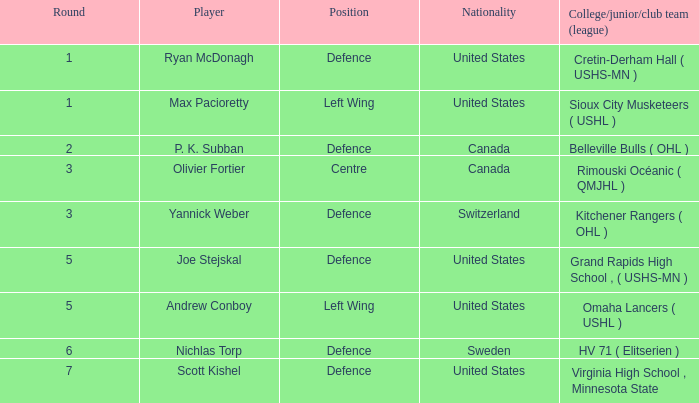Could you parse the entire table as a dict? {'header': ['Round', 'Player', 'Position', 'Nationality', 'College/junior/club team (league)'], 'rows': [['1', 'Ryan McDonagh', 'Defence', 'United States', 'Cretin-Derham Hall ( USHS-MN )'], ['1', 'Max Pacioretty', 'Left Wing', 'United States', 'Sioux City Musketeers ( USHL )'], ['2', 'P. K. Subban', 'Defence', 'Canada', 'Belleville Bulls ( OHL )'], ['3', 'Olivier Fortier', 'Centre', 'Canada', 'Rimouski Océanic ( QMJHL )'], ['3', 'Yannick Weber', 'Defence', 'Switzerland', 'Kitchener Rangers ( OHL )'], ['5', 'Joe Stejskal', 'Defence', 'United States', 'Grand Rapids High School , ( USHS-MN )'], ['5', 'Andrew Conboy', 'Left Wing', 'United States', 'Omaha Lancers ( USHL )'], ['6', 'Nichlas Torp', 'Defence', 'Sweden', 'HV 71 ( Elitserien )'], ['7', 'Scott Kishel', 'Defence', 'United States', 'Virginia High School , Minnesota State']]} Which College/junior/club team (league) was the player from Switzerland from? Kitchener Rangers ( OHL ). 